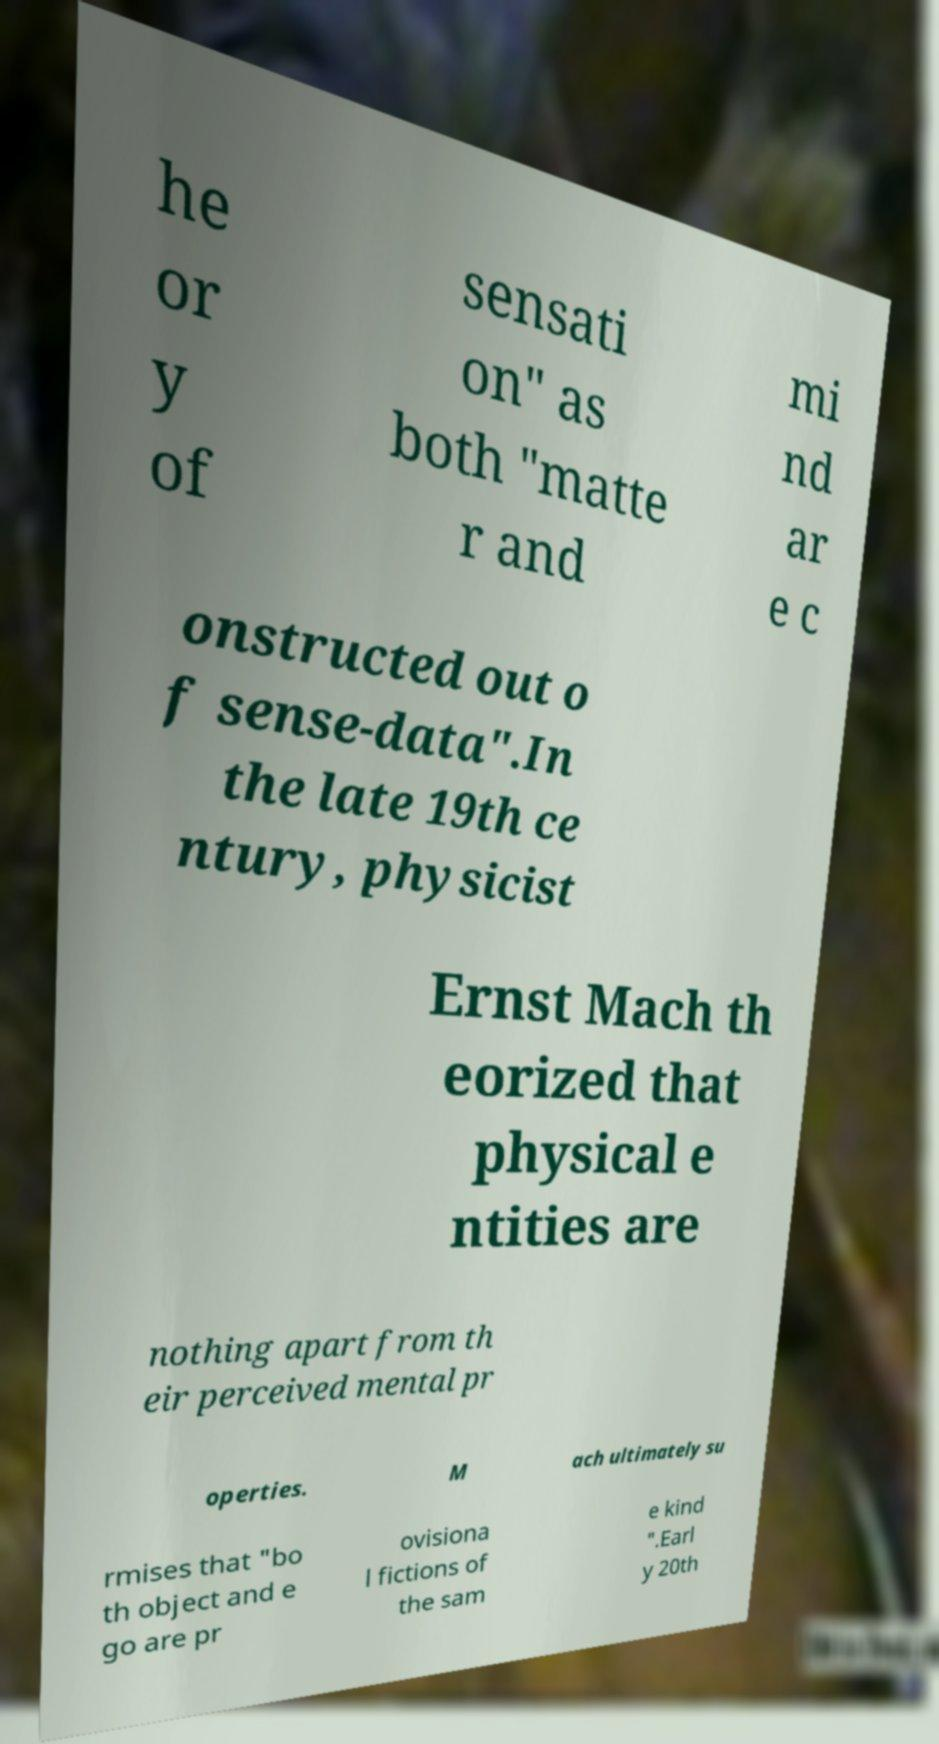Could you extract and type out the text from this image? he or y of sensati on" as both "matte r and mi nd ar e c onstructed out o f sense-data".In the late 19th ce ntury, physicist Ernst Mach th eorized that physical e ntities are nothing apart from th eir perceived mental pr operties. M ach ultimately su rmises that "bo th object and e go are pr ovisiona l fictions of the sam e kind ".Earl y 20th 